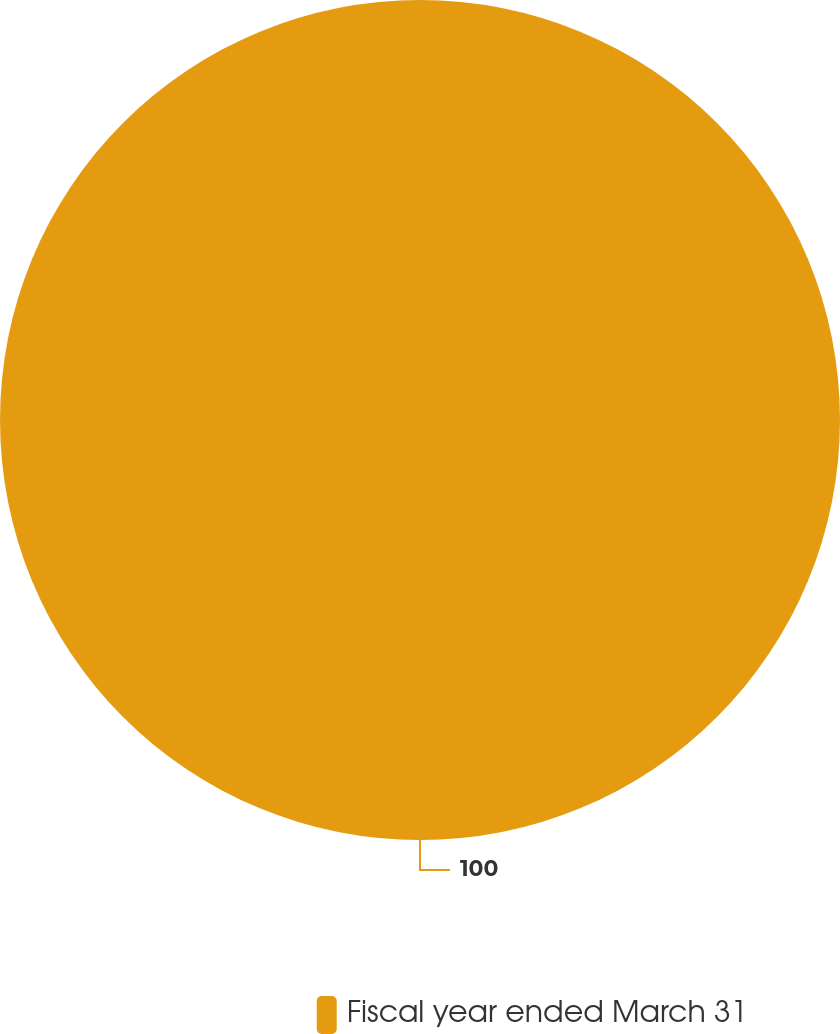Convert chart to OTSL. <chart><loc_0><loc_0><loc_500><loc_500><pie_chart><fcel>Fiscal year ended March 31<nl><fcel>100.0%<nl></chart> 